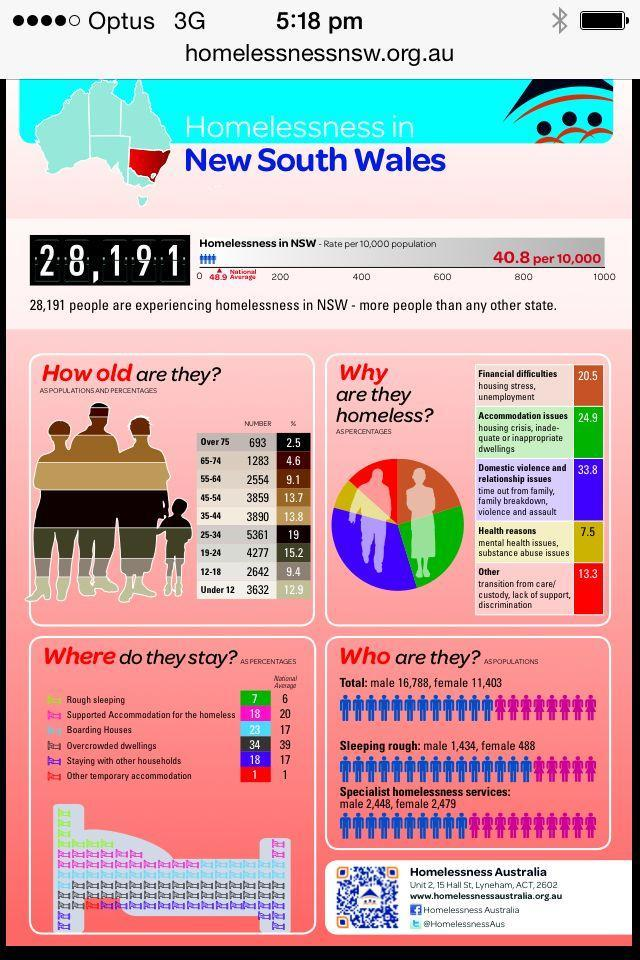What percentage of people in NSW are homeless due to financial difficulties?
Answer the question with a short phrase. 20.5 What percentage of people in NSW are homeless due to health reasons? 7.5 What is the percentage of homelessness in the age group of 75+ years in NSW? 2.5 What is the percentage of homelessness in the age group of 45-54 years in NSW? 13.7 What is the national average of homeless people who live in overcrowded dwellings in NSW? 39 How many people in the age group of 65-74 years are homeless in NSW? 1283 What is the national average of rough sleeping homeless people in NSW? 6 How many people in the age group of 12-18 years are homeless in NSW? 2642 